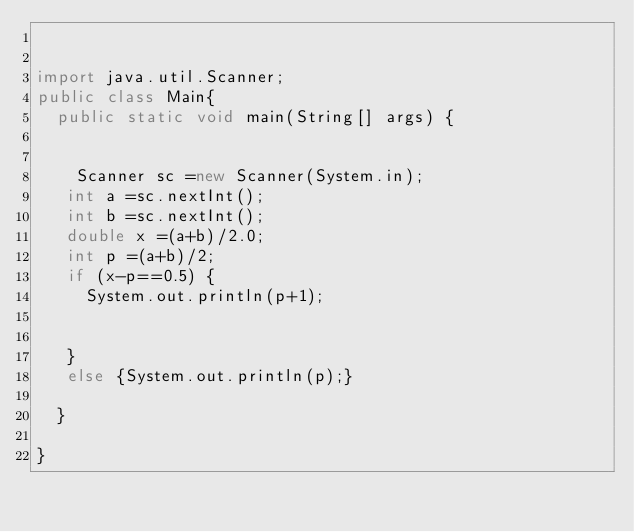Convert code to text. <code><loc_0><loc_0><loc_500><loc_500><_Java_>

import java.util.Scanner;
public class Main{
	public static void main(String[] args) {


    Scanner sc =new Scanner(System.in);
   int a =sc.nextInt();
   int b =sc.nextInt();
   double x =(a+b)/2.0;
   int p =(a+b)/2;
   if (x-p==0.5) {
	   System.out.println(p+1);


   }
   else {System.out.println(p);}

	}

}
</code> 